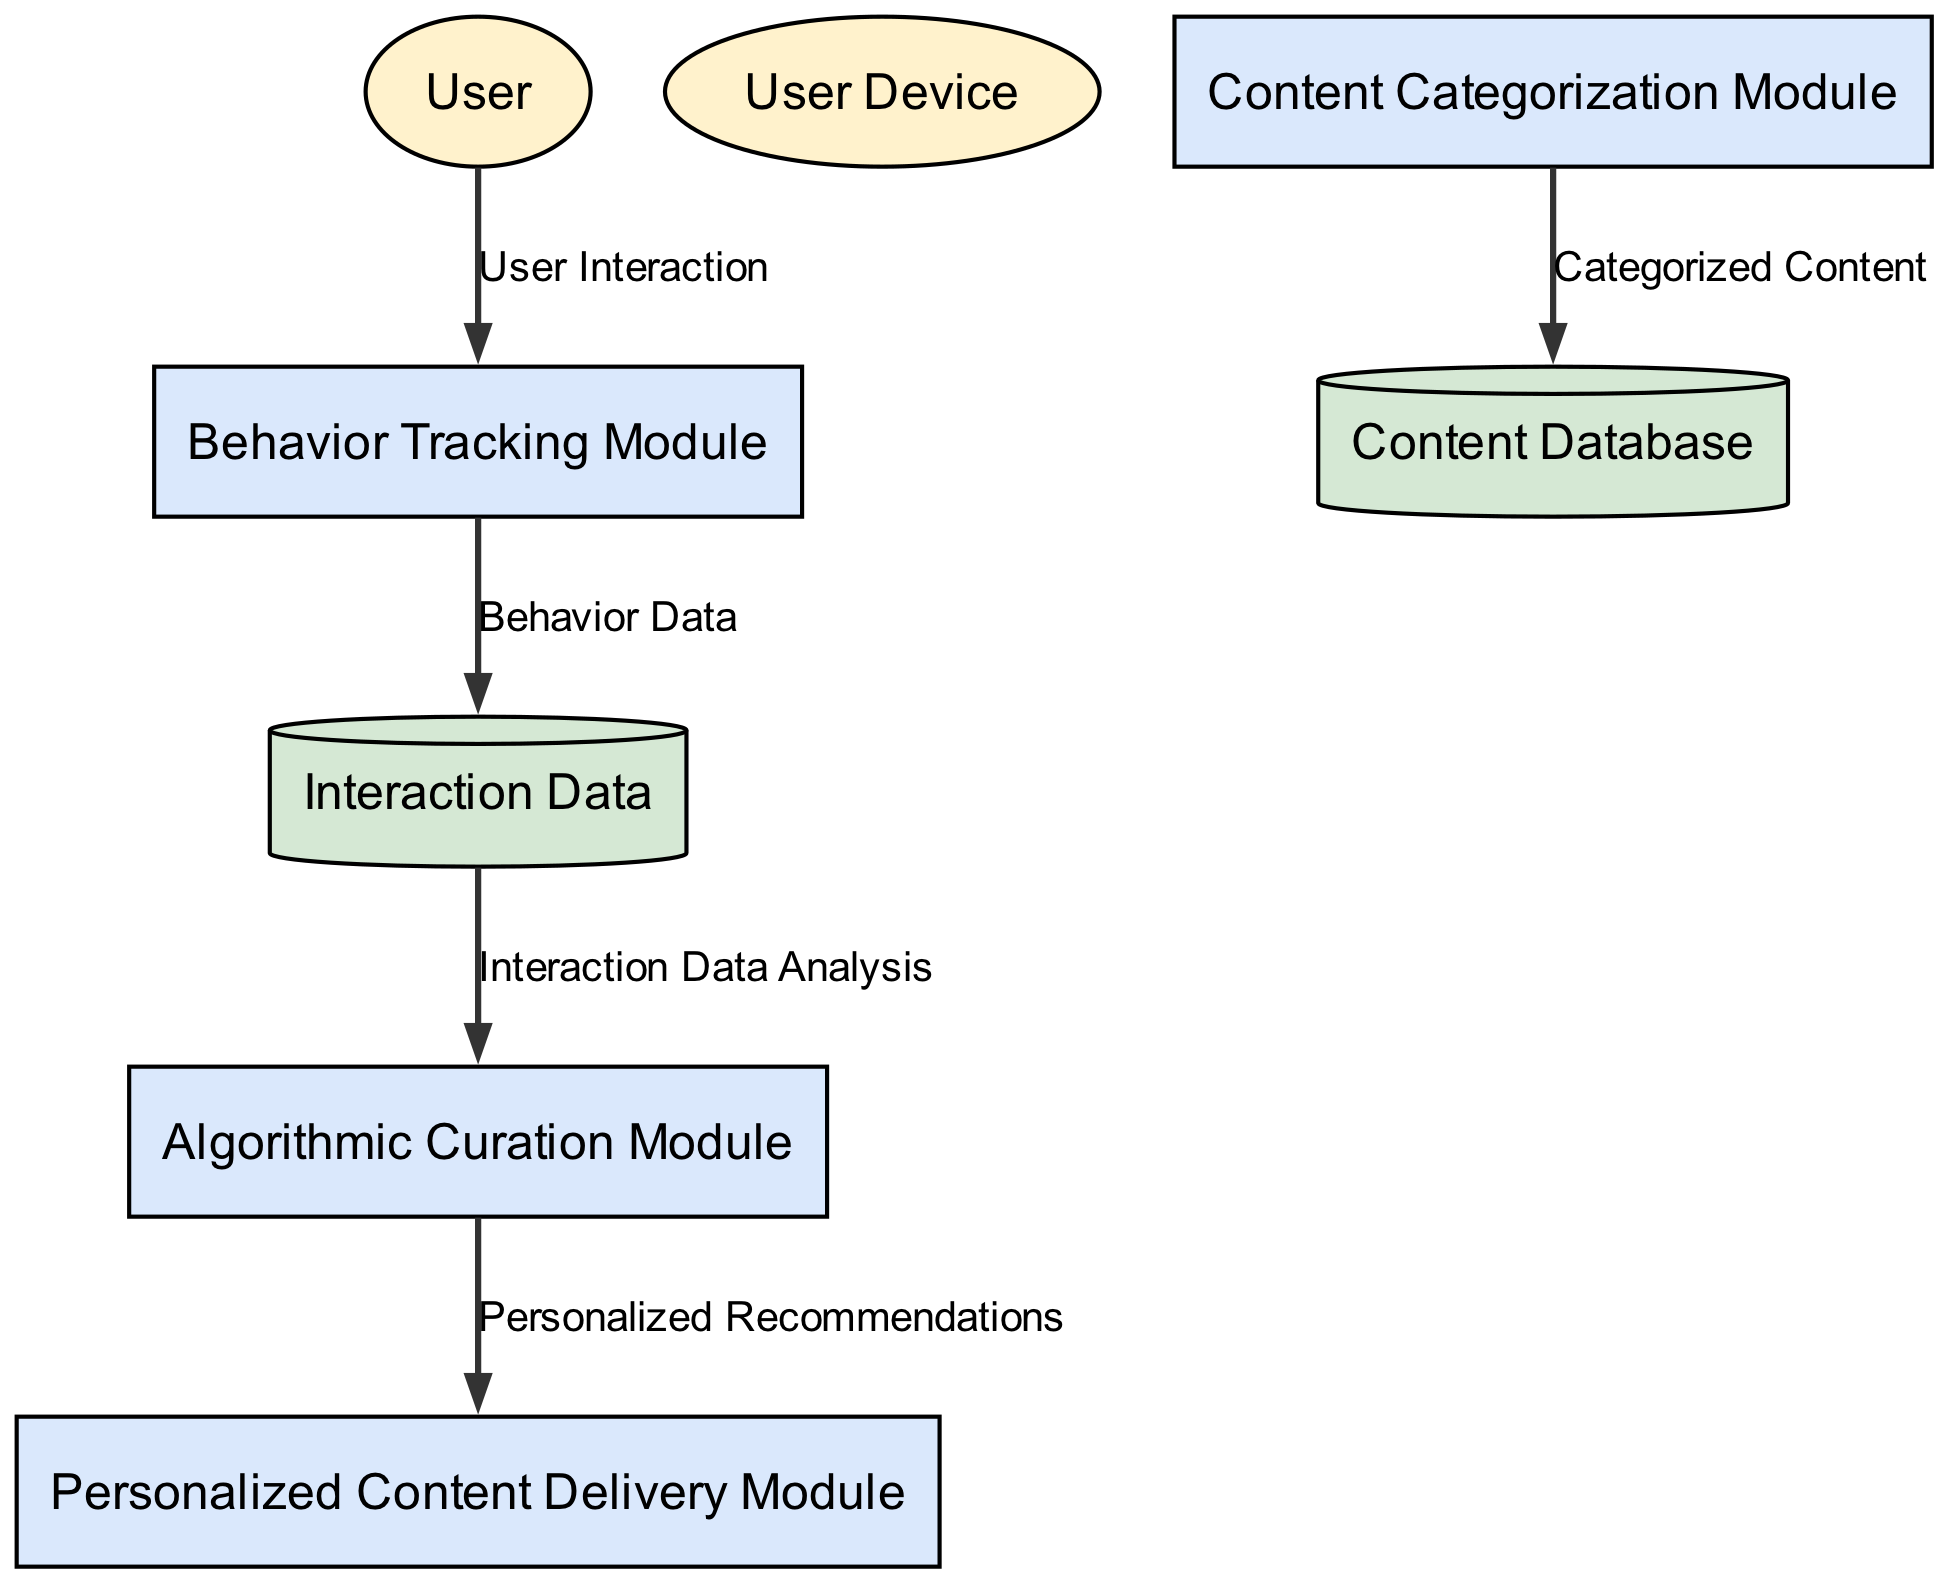What are the data stores in this diagram? The diagram includes two data stores: "Interaction Data" and "Content Database." These represent the repositories for storing specific information related to user interactions and available content, respectively.
Answer: Interaction Data, Content Database How many external entities are represented in the diagram? The diagram shows two external entities: "User" and "User Device." These entities interact with the system and represent the users engaging with the application.
Answer: 2 Which module is responsible for delivering personalized recommendations? The "Personalized Content Delivery Module" is the component designated for the task of delivering personalized content that is tailored for individual users based on their interaction data.
Answer: Personalized Content Delivery Module What type of entity is "Content Database"? In the diagram, "Content Database" is classified as a data store. This means it functions as a repository for storing categorized content that is available for recommendations.
Answer: Data store How does the Interaction Data influence the Algorithmic Curation Module? "Interaction Data" supplies the "Algorithmic Curation Module" with essential data derived from user behavior, which is necessary for generating personalized recommendations. This flow allows the curation module to process the data and tailor content effectively.
Answer: Interaction Data Analysis Which process captures user interactions? The "Behavior Tracking Module" is the specific process that captures and logs various user interactions, such as clicks and time spent on content. This process is crucial for gathering the raw data needed for subsequent analysis.
Answer: Behavior Tracking Module How many data flows are there in the diagram? The diagram includes six data flows, each indicating the movement of data between different modules and data stores, illustrating how various components interact with one another.
Answer: 6 Which module categorizes content? The "Content Categorization Module" is the process responsible for analyzing content and assigning categories, facilitating better organization and retrieval of content in the system.
Answer: Content Categorization Module What type of data flow is represented from the Algorithmic Curation Module to the Personalized Content Delivery Module? This flow is described as "Personalized Recommendations," which indicates the transfer of curated content exclusively ready for delivery to individual users based on their preferences and interactions.
Answer: Personalized Recommendations 